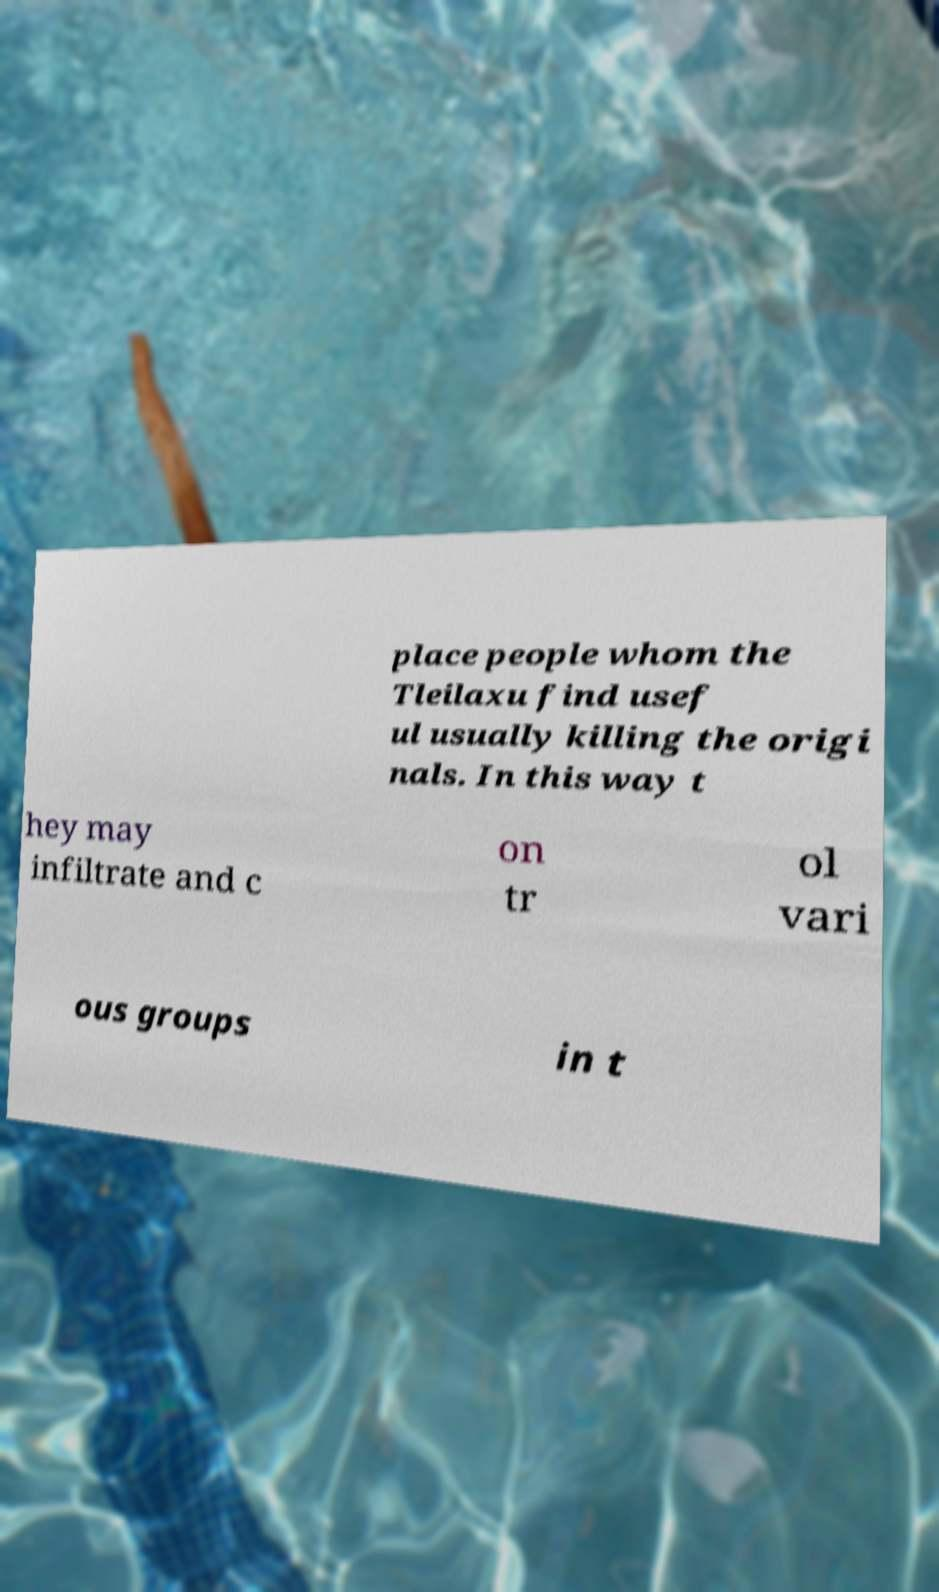Please identify and transcribe the text found in this image. place people whom the Tleilaxu find usef ul usually killing the origi nals. In this way t hey may infiltrate and c on tr ol vari ous groups in t 